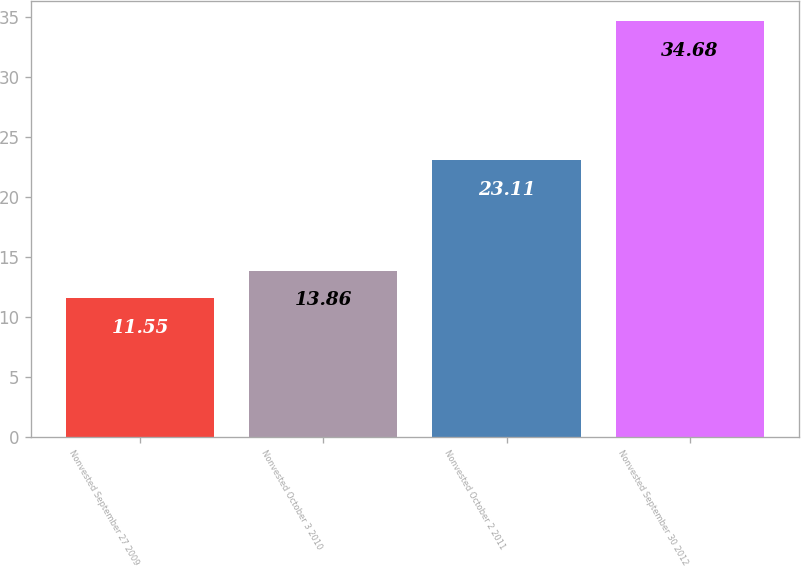Convert chart. <chart><loc_0><loc_0><loc_500><loc_500><bar_chart><fcel>Nonvested September 27 2009<fcel>Nonvested October 3 2010<fcel>Nonvested October 2 2011<fcel>Nonvested September 30 2012<nl><fcel>11.55<fcel>13.86<fcel>23.11<fcel>34.68<nl></chart> 